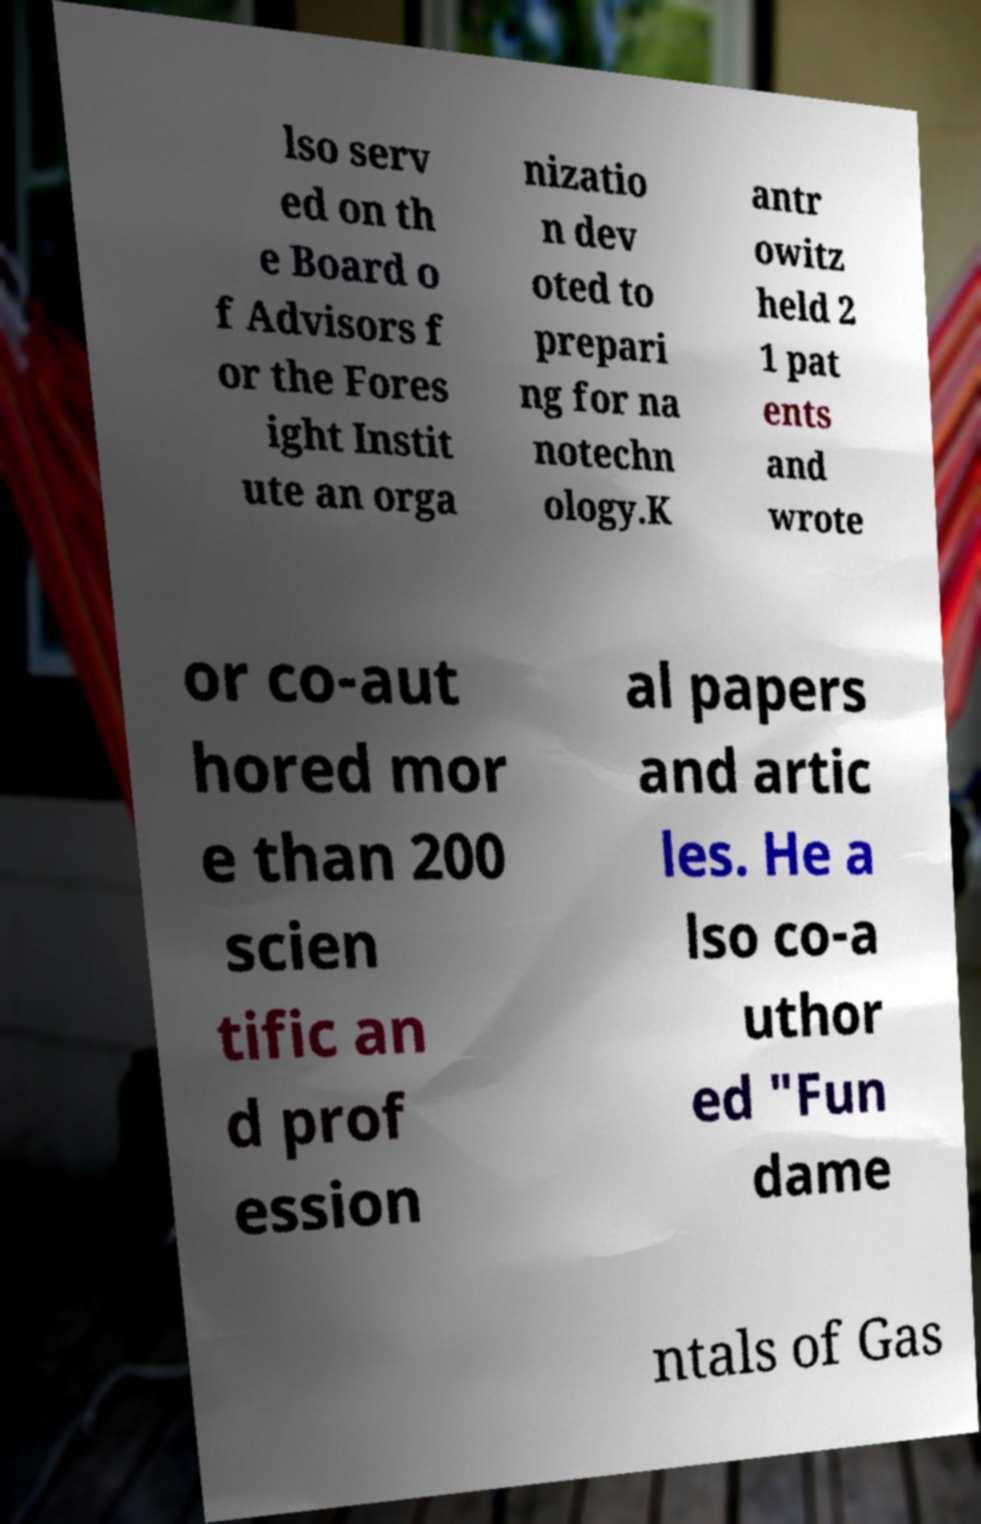Please identify and transcribe the text found in this image. lso serv ed on th e Board o f Advisors f or the Fores ight Instit ute an orga nizatio n dev oted to prepari ng for na notechn ology.K antr owitz held 2 1 pat ents and wrote or co-aut hored mor e than 200 scien tific an d prof ession al papers and artic les. He a lso co-a uthor ed "Fun dame ntals of Gas 